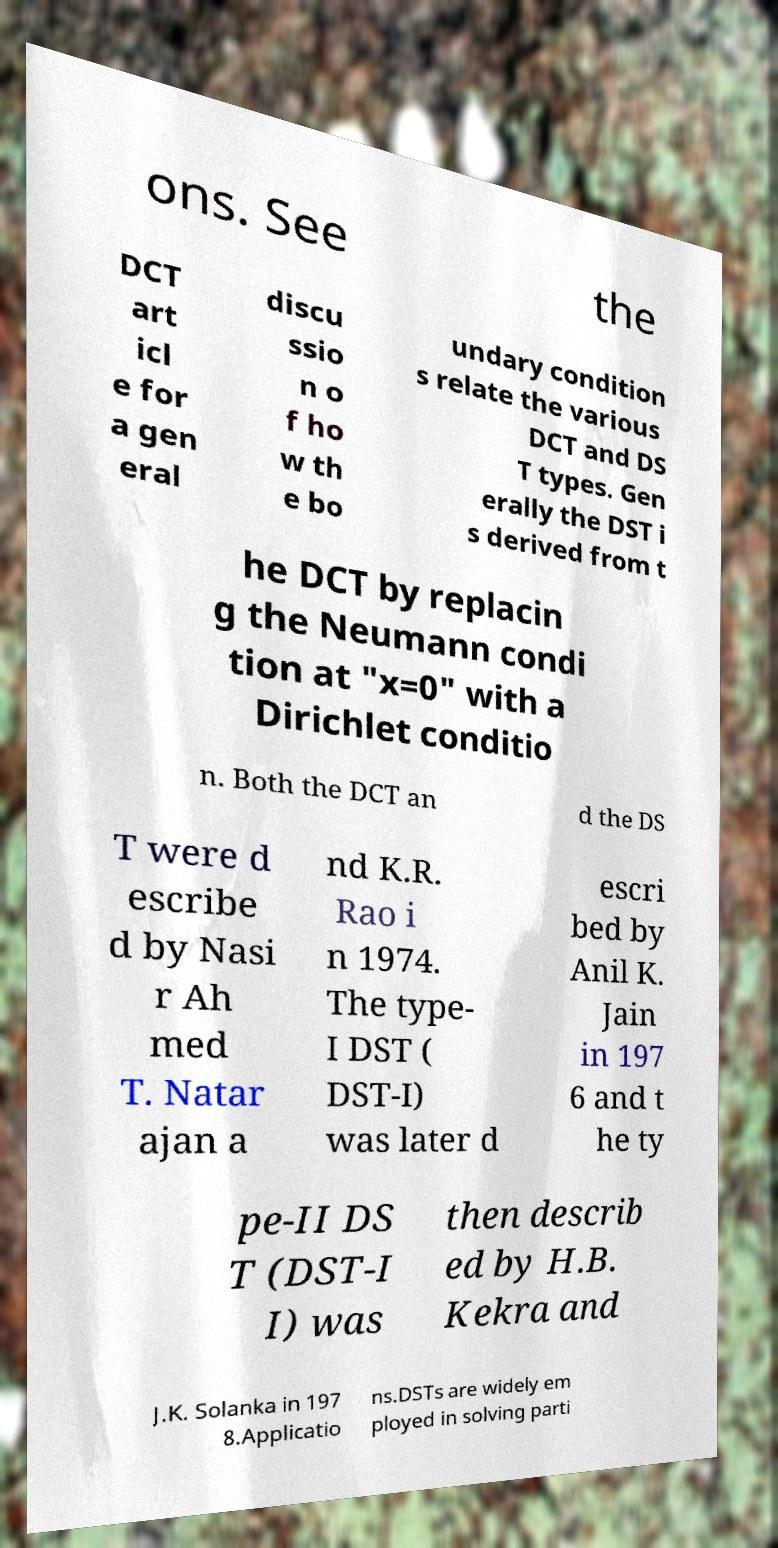I need the written content from this picture converted into text. Can you do that? ons. See the DCT art icl e for a gen eral discu ssio n o f ho w th e bo undary condition s relate the various DCT and DS T types. Gen erally the DST i s derived from t he DCT by replacin g the Neumann condi tion at "x=0" with a Dirichlet conditio n. Both the DCT an d the DS T were d escribe d by Nasi r Ah med T. Natar ajan a nd K.R. Rao i n 1974. The type- I DST ( DST-I) was later d escri bed by Anil K. Jain in 197 6 and t he ty pe-II DS T (DST-I I) was then describ ed by H.B. Kekra and J.K. Solanka in 197 8.Applicatio ns.DSTs are widely em ployed in solving parti 